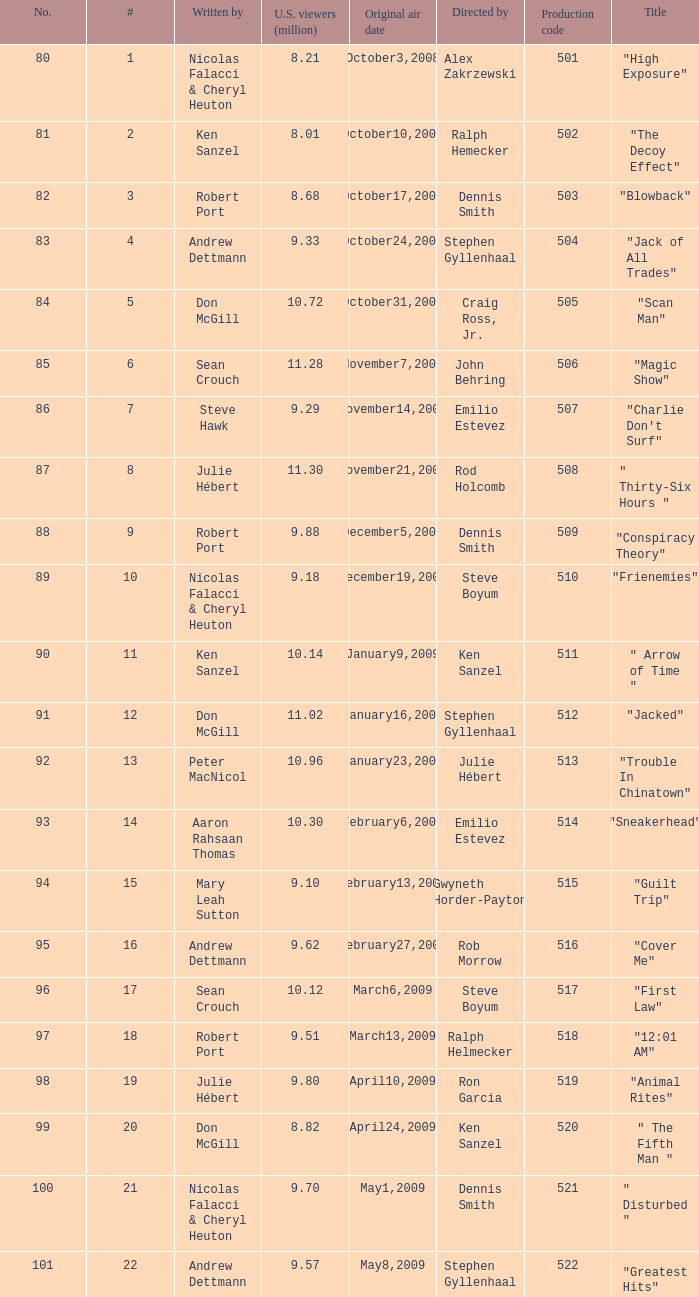What episode number was directed by Craig Ross, Jr. 5.0. 